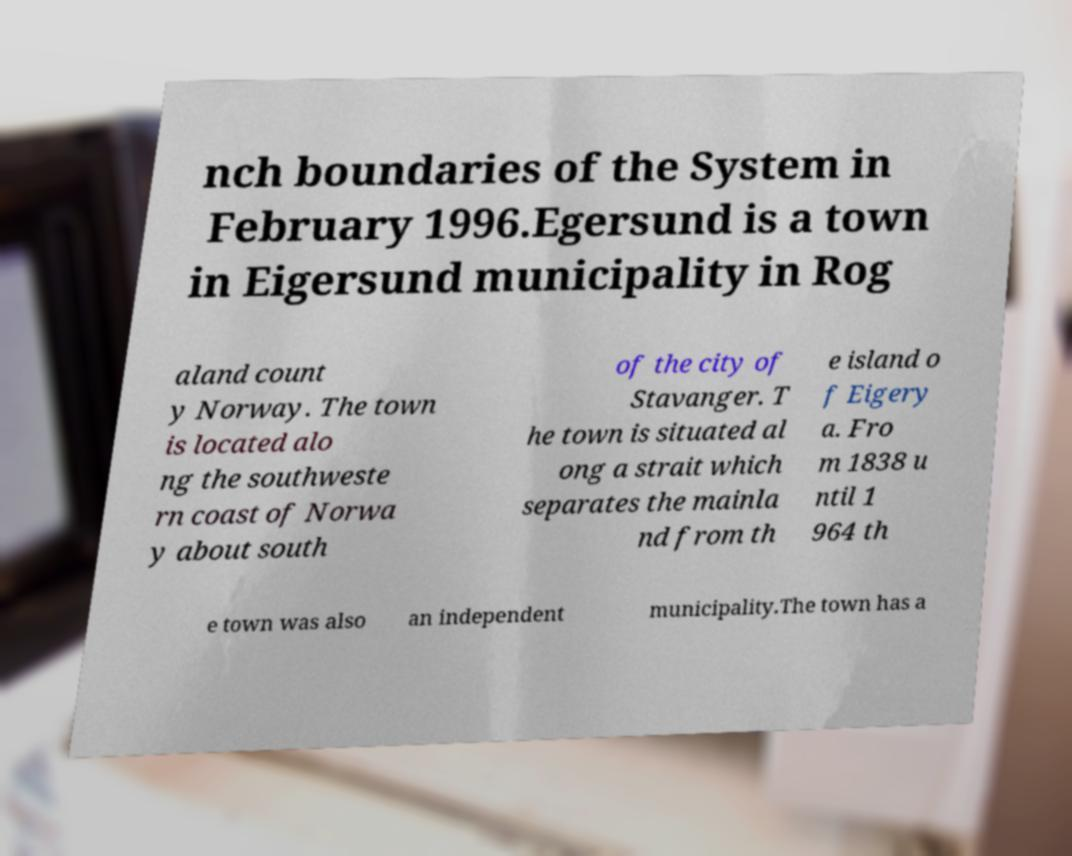Could you extract and type out the text from this image? nch boundaries of the System in February 1996.Egersund is a town in Eigersund municipality in Rog aland count y Norway. The town is located alo ng the southweste rn coast of Norwa y about south of the city of Stavanger. T he town is situated al ong a strait which separates the mainla nd from th e island o f Eigery a. Fro m 1838 u ntil 1 964 th e town was also an independent municipality.The town has a 